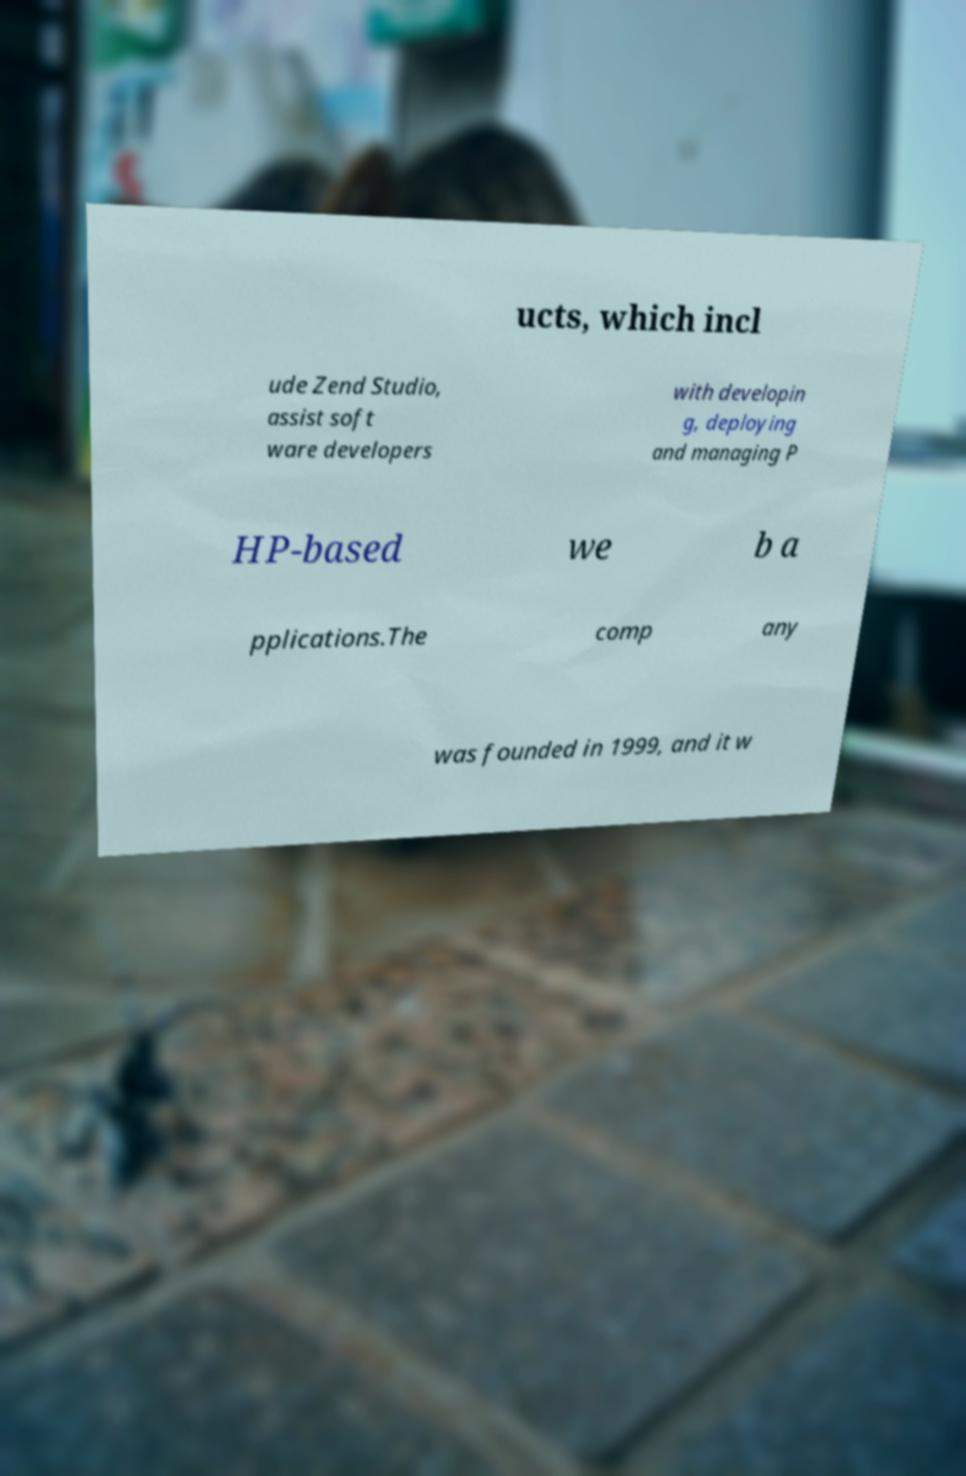Can you accurately transcribe the text from the provided image for me? ucts, which incl ude Zend Studio, assist soft ware developers with developin g, deploying and managing P HP-based we b a pplications.The comp any was founded in 1999, and it w 